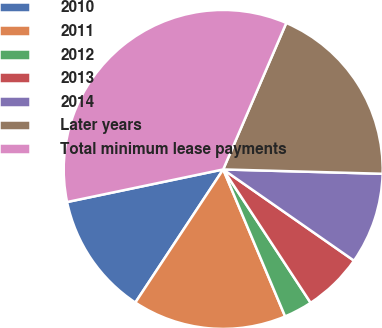<chart> <loc_0><loc_0><loc_500><loc_500><pie_chart><fcel>2010<fcel>2011<fcel>2012<fcel>2013<fcel>2014<fcel>Later years<fcel>Total minimum lease payments<nl><fcel>12.44%<fcel>15.63%<fcel>2.89%<fcel>6.07%<fcel>9.26%<fcel>18.96%<fcel>34.75%<nl></chart> 